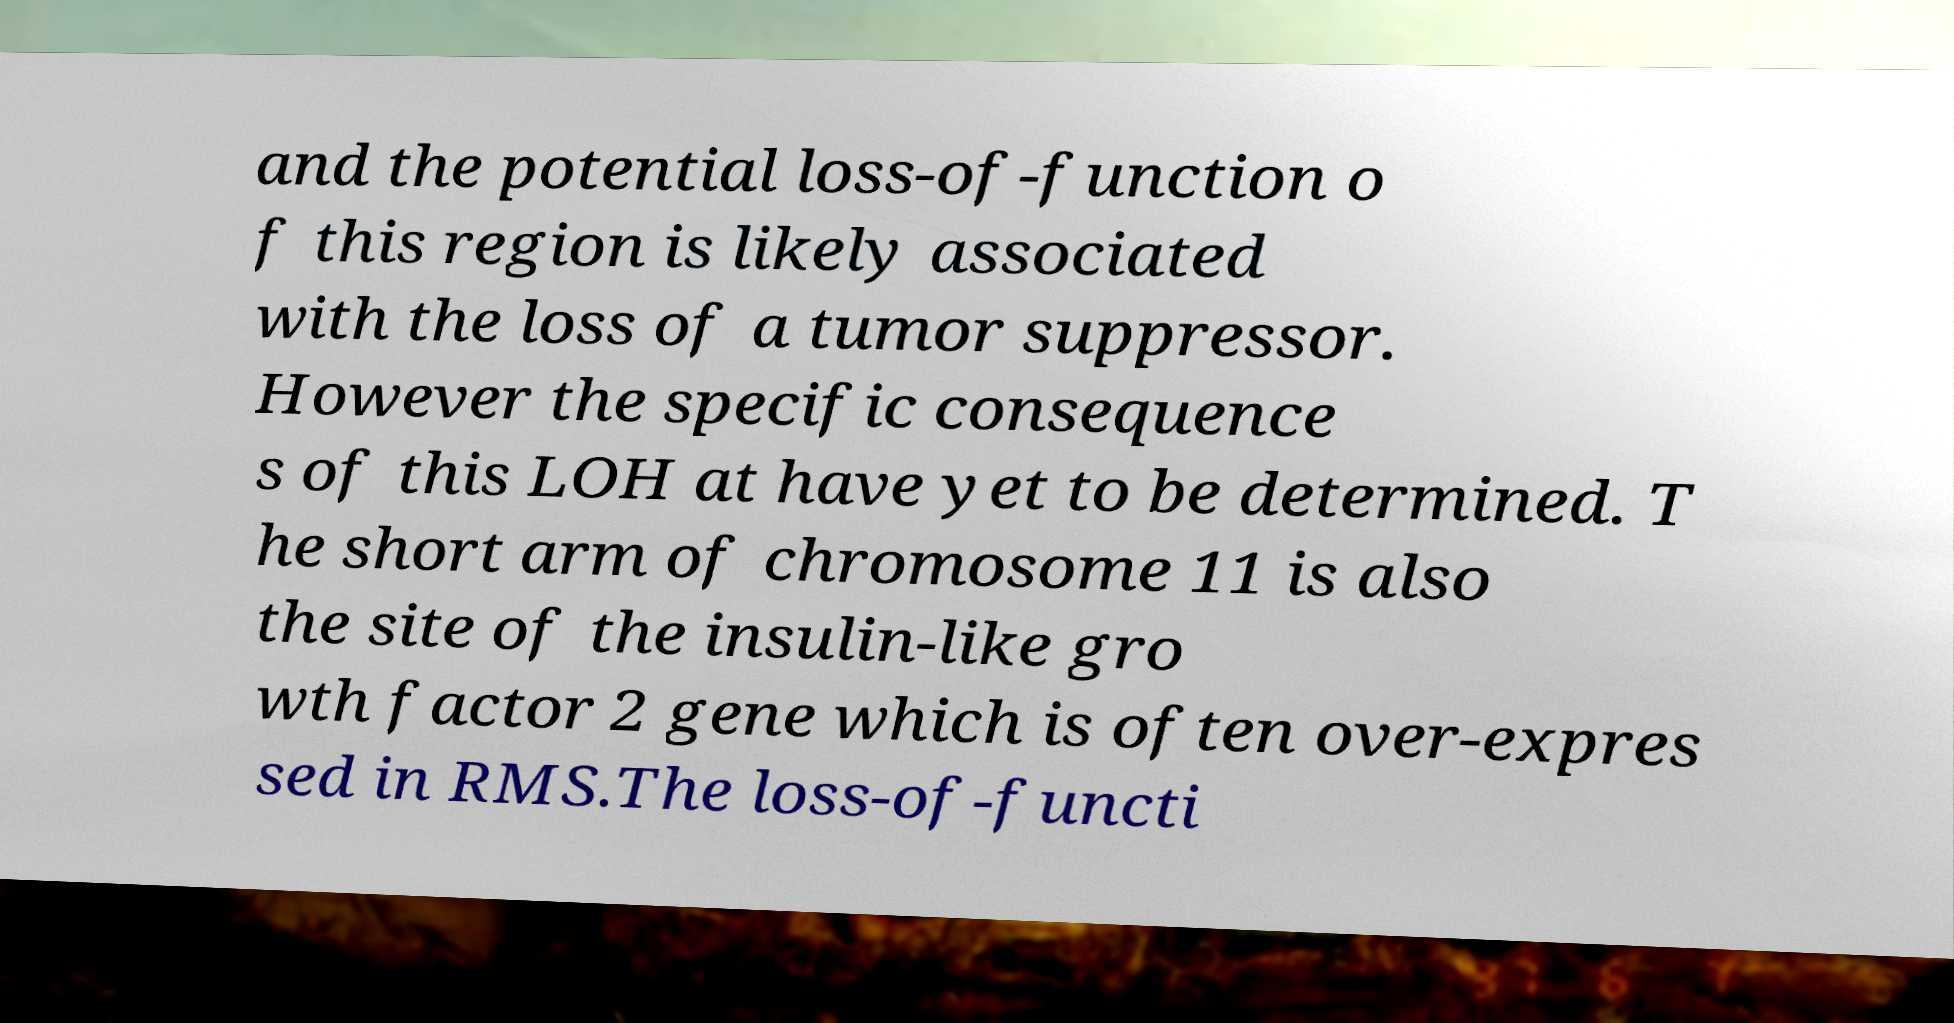Can you read and provide the text displayed in the image?This photo seems to have some interesting text. Can you extract and type it out for me? and the potential loss-of-function o f this region is likely associated with the loss of a tumor suppressor. However the specific consequence s of this LOH at have yet to be determined. T he short arm of chromosome 11 is also the site of the insulin-like gro wth factor 2 gene which is often over-expres sed in RMS.The loss-of-functi 